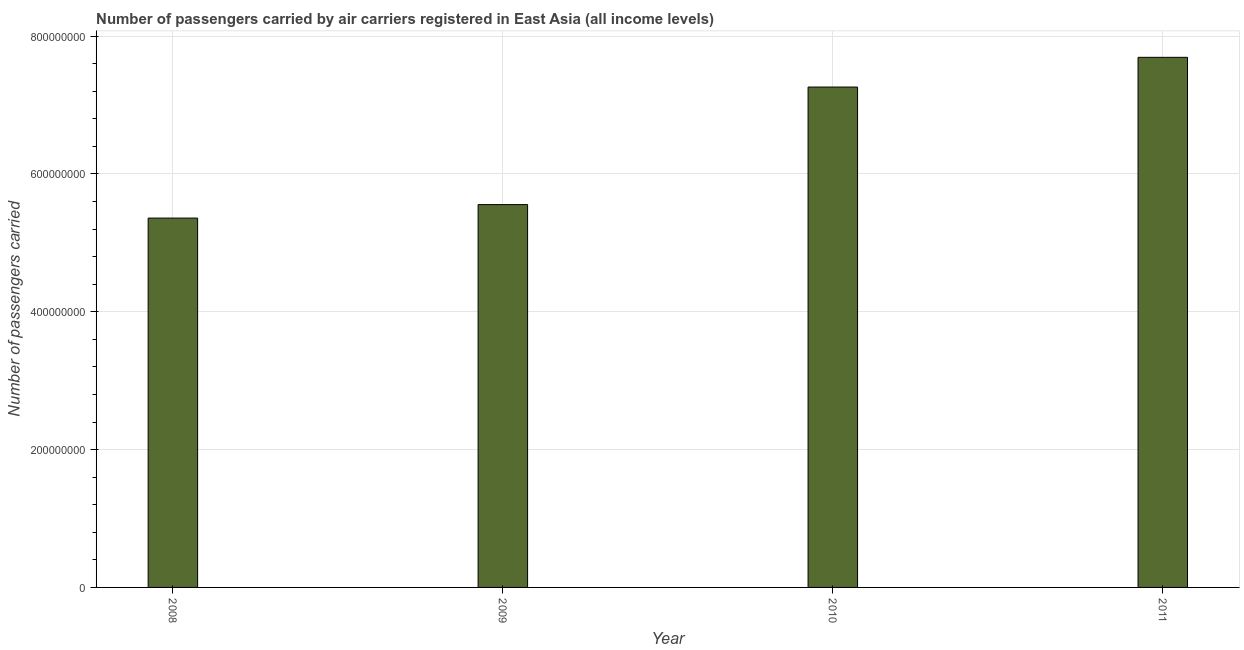Does the graph contain any zero values?
Provide a succinct answer. No. Does the graph contain grids?
Keep it short and to the point. Yes. What is the title of the graph?
Ensure brevity in your answer.  Number of passengers carried by air carriers registered in East Asia (all income levels). What is the label or title of the Y-axis?
Offer a terse response. Number of passengers carried. What is the number of passengers carried in 2010?
Offer a very short reply. 7.26e+08. Across all years, what is the maximum number of passengers carried?
Offer a terse response. 7.69e+08. Across all years, what is the minimum number of passengers carried?
Provide a succinct answer. 5.36e+08. In which year was the number of passengers carried minimum?
Provide a short and direct response. 2008. What is the sum of the number of passengers carried?
Give a very brief answer. 2.59e+09. What is the difference between the number of passengers carried in 2008 and 2011?
Keep it short and to the point. -2.33e+08. What is the average number of passengers carried per year?
Your answer should be compact. 6.47e+08. What is the median number of passengers carried?
Keep it short and to the point. 6.41e+08. In how many years, is the number of passengers carried greater than 760000000 ?
Offer a terse response. 1. Do a majority of the years between 2009 and 2011 (inclusive) have number of passengers carried greater than 120000000 ?
Offer a terse response. Yes. What is the ratio of the number of passengers carried in 2008 to that in 2010?
Your answer should be very brief. 0.74. What is the difference between the highest and the second highest number of passengers carried?
Offer a terse response. 4.31e+07. Is the sum of the number of passengers carried in 2008 and 2010 greater than the maximum number of passengers carried across all years?
Make the answer very short. Yes. What is the difference between the highest and the lowest number of passengers carried?
Ensure brevity in your answer.  2.33e+08. In how many years, is the number of passengers carried greater than the average number of passengers carried taken over all years?
Provide a short and direct response. 2. What is the difference between two consecutive major ticks on the Y-axis?
Ensure brevity in your answer.  2.00e+08. Are the values on the major ticks of Y-axis written in scientific E-notation?
Provide a succinct answer. No. What is the Number of passengers carried of 2008?
Your response must be concise. 5.36e+08. What is the Number of passengers carried in 2009?
Provide a short and direct response. 5.55e+08. What is the Number of passengers carried in 2010?
Keep it short and to the point. 7.26e+08. What is the Number of passengers carried of 2011?
Provide a short and direct response. 7.69e+08. What is the difference between the Number of passengers carried in 2008 and 2009?
Ensure brevity in your answer.  -1.96e+07. What is the difference between the Number of passengers carried in 2008 and 2010?
Make the answer very short. -1.90e+08. What is the difference between the Number of passengers carried in 2008 and 2011?
Offer a very short reply. -2.33e+08. What is the difference between the Number of passengers carried in 2009 and 2010?
Your response must be concise. -1.71e+08. What is the difference between the Number of passengers carried in 2009 and 2011?
Make the answer very short. -2.14e+08. What is the difference between the Number of passengers carried in 2010 and 2011?
Your answer should be compact. -4.31e+07. What is the ratio of the Number of passengers carried in 2008 to that in 2010?
Provide a succinct answer. 0.74. What is the ratio of the Number of passengers carried in 2008 to that in 2011?
Your answer should be compact. 0.7. What is the ratio of the Number of passengers carried in 2009 to that in 2010?
Offer a very short reply. 0.77. What is the ratio of the Number of passengers carried in 2009 to that in 2011?
Your answer should be compact. 0.72. What is the ratio of the Number of passengers carried in 2010 to that in 2011?
Make the answer very short. 0.94. 